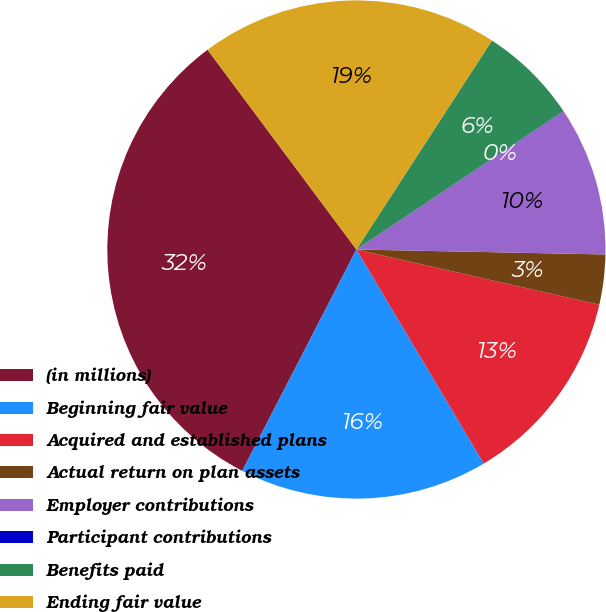<chart> <loc_0><loc_0><loc_500><loc_500><pie_chart><fcel>(in millions)<fcel>Beginning fair value<fcel>Acquired and established plans<fcel>Actual return on plan assets<fcel>Employer contributions<fcel>Participant contributions<fcel>Benefits paid<fcel>Ending fair value<nl><fcel>32.23%<fcel>16.12%<fcel>12.9%<fcel>3.24%<fcel>9.68%<fcel>0.02%<fcel>6.46%<fcel>19.35%<nl></chart> 